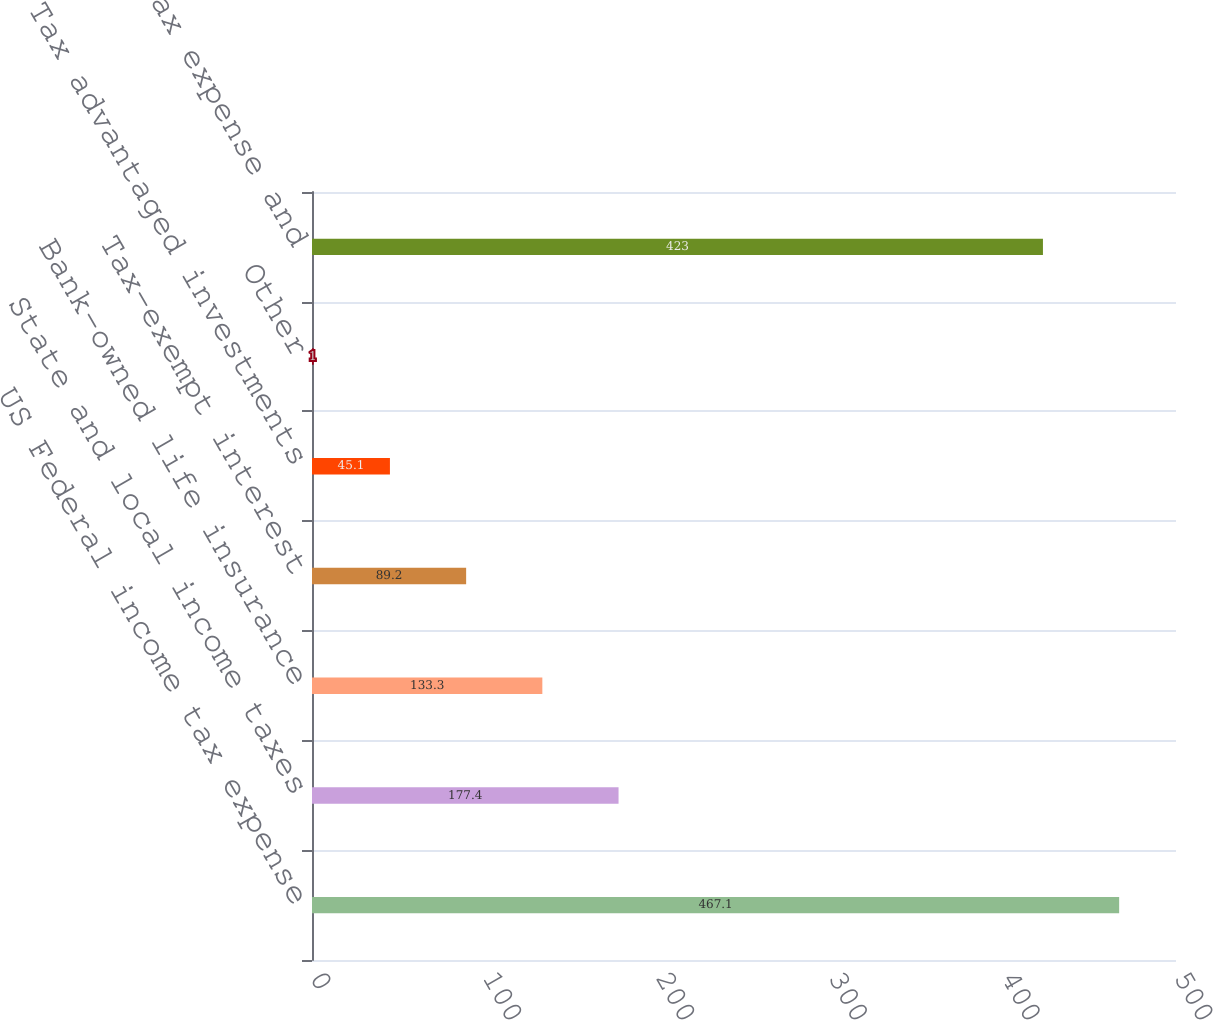Convert chart to OTSL. <chart><loc_0><loc_0><loc_500><loc_500><bar_chart><fcel>US Federal income tax expense<fcel>State and local income taxes<fcel>Bank-owned life insurance<fcel>Tax-exempt interest<fcel>Tax advantaged investments<fcel>Other<fcel>Total income tax expense and<nl><fcel>467.1<fcel>177.4<fcel>133.3<fcel>89.2<fcel>45.1<fcel>1<fcel>423<nl></chart> 